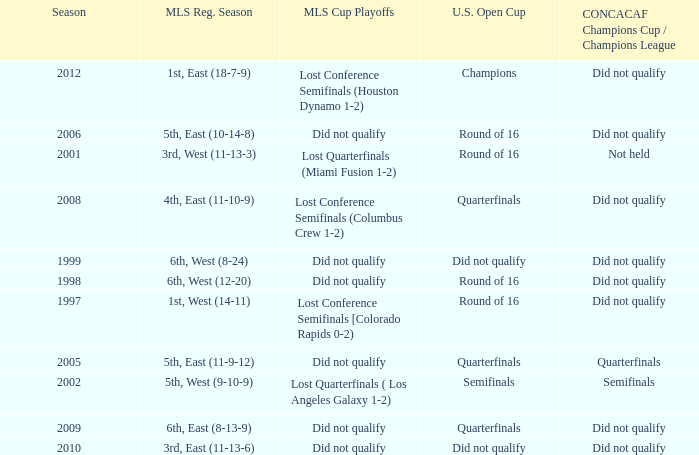Can you give me this table as a dict? {'header': ['Season', 'MLS Reg. Season', 'MLS Cup Playoffs', 'U.S. Open Cup', 'CONCACAF Champions Cup / Champions League'], 'rows': [['2012', '1st, East (18-7-9)', 'Lost Conference Semifinals (Houston Dynamo 1-2)', 'Champions', 'Did not qualify'], ['2006', '5th, East (10-14-8)', 'Did not qualify', 'Round of 16', 'Did not qualify'], ['2001', '3rd, West (11-13-3)', 'Lost Quarterfinals (Miami Fusion 1-2)', 'Round of 16', 'Not held'], ['2008', '4th, East (11-10-9)', 'Lost Conference Semifinals (Columbus Crew 1-2)', 'Quarterfinals', 'Did not qualify'], ['1999', '6th, West (8-24)', 'Did not qualify', 'Did not qualify', 'Did not qualify'], ['1998', '6th, West (12-20)', 'Did not qualify', 'Round of 16', 'Did not qualify'], ['1997', '1st, West (14-11)', 'Lost Conference Semifinals [Colorado Rapids 0-2)', 'Round of 16', 'Did not qualify'], ['2005', '5th, East (11-9-12)', 'Did not qualify', 'Quarterfinals', 'Quarterfinals'], ['2002', '5th, West (9-10-9)', 'Lost Quarterfinals ( Los Angeles Galaxy 1-2)', 'Semifinals', 'Semifinals'], ['2009', '6th, East (8-13-9)', 'Did not qualify', 'Quarterfinals', 'Did not qualify'], ['2010', '3rd, East (11-13-6)', 'Did not qualify', 'Did not qualify', 'Did not qualify']]} How did the team place when they did not qualify for the Concaf Champions Cup but made it to Round of 16 in the U.S. Open Cup? Lost Conference Semifinals [Colorado Rapids 0-2), Did not qualify, Did not qualify. 